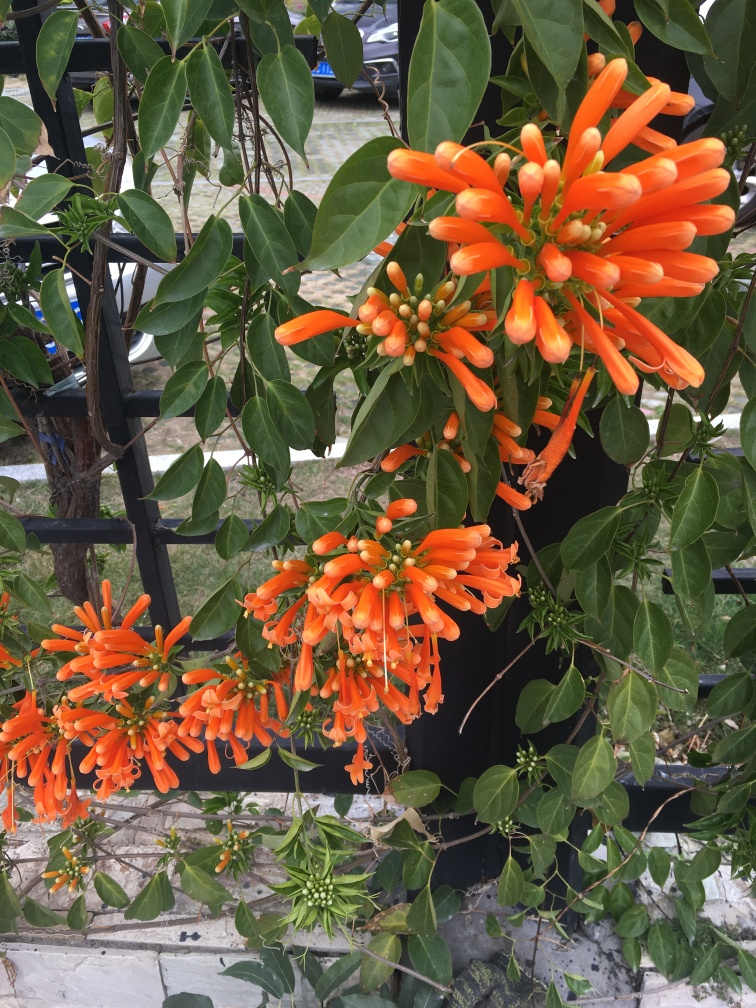What time of year do these flowers typically bloom? The flame vine typically blooms in the cooler months of winter and spring, providing a burst of color during a time when many other plants are not flowering. How can these flowers benefit the local ecosystem? These flowers can attract a variety of pollinators, including bees and hummingbirds, which are important for the pollination of other plants. Additionally, they can provide cover and habitat for small animals and insects. 